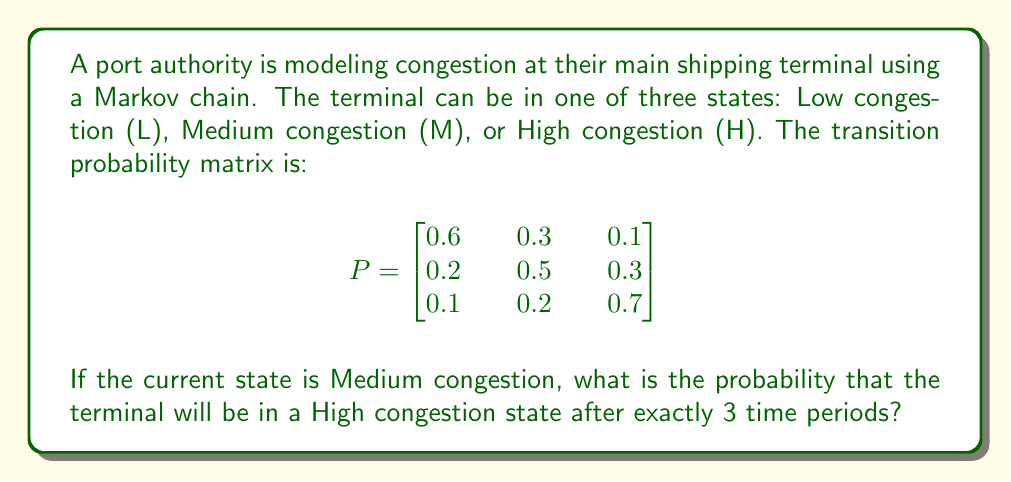Provide a solution to this math problem. To solve this problem, we need to use the Chapman-Kolmogorov equations and matrix multiplication. The steps are as follows:

1) The initial state vector is $v_0 = [0 \quad 1 \quad 0]$, representing Medium congestion.

2) We need to calculate $v_0 \cdot P^3$, where $P^3$ is the transition matrix raised to the power of 3.

3) To calculate $P^3$, we multiply P by itself three times:

   $$P^2 = P \cdot P = \begin{bmatrix}
   0.42 & 0.33 & 0.25 \\
   0.23 & 0.37 & 0.40 \\
   0.17 & 0.25 & 0.58
   \end{bmatrix}$$

   $$P^3 = P^2 \cdot P = \begin{bmatrix}
   0.331 & 0.312 & 0.357 \\
   0.247 & 0.308 & 0.445 \\
   0.199 & 0.263 & 0.538
   \end{bmatrix}$$

4) Now, we multiply $v_0$ by $P^3$:

   $v_3 = v_0 \cdot P^3 = [0 \quad 1 \quad 0] \cdot \begin{bmatrix}
   0.331 & 0.312 & 0.357 \\
   0.247 & 0.308 & 0.445 \\
   0.199 & 0.263 & 0.538
   \end{bmatrix}$

5) This multiplication results in:

   $v_3 = [0.247 \quad 0.308 \quad 0.445]$

6) The probability of being in the High congestion state after 3 time periods is the third element of this vector, which is 0.445 or 44.5%.
Answer: 0.445 or 44.5% 